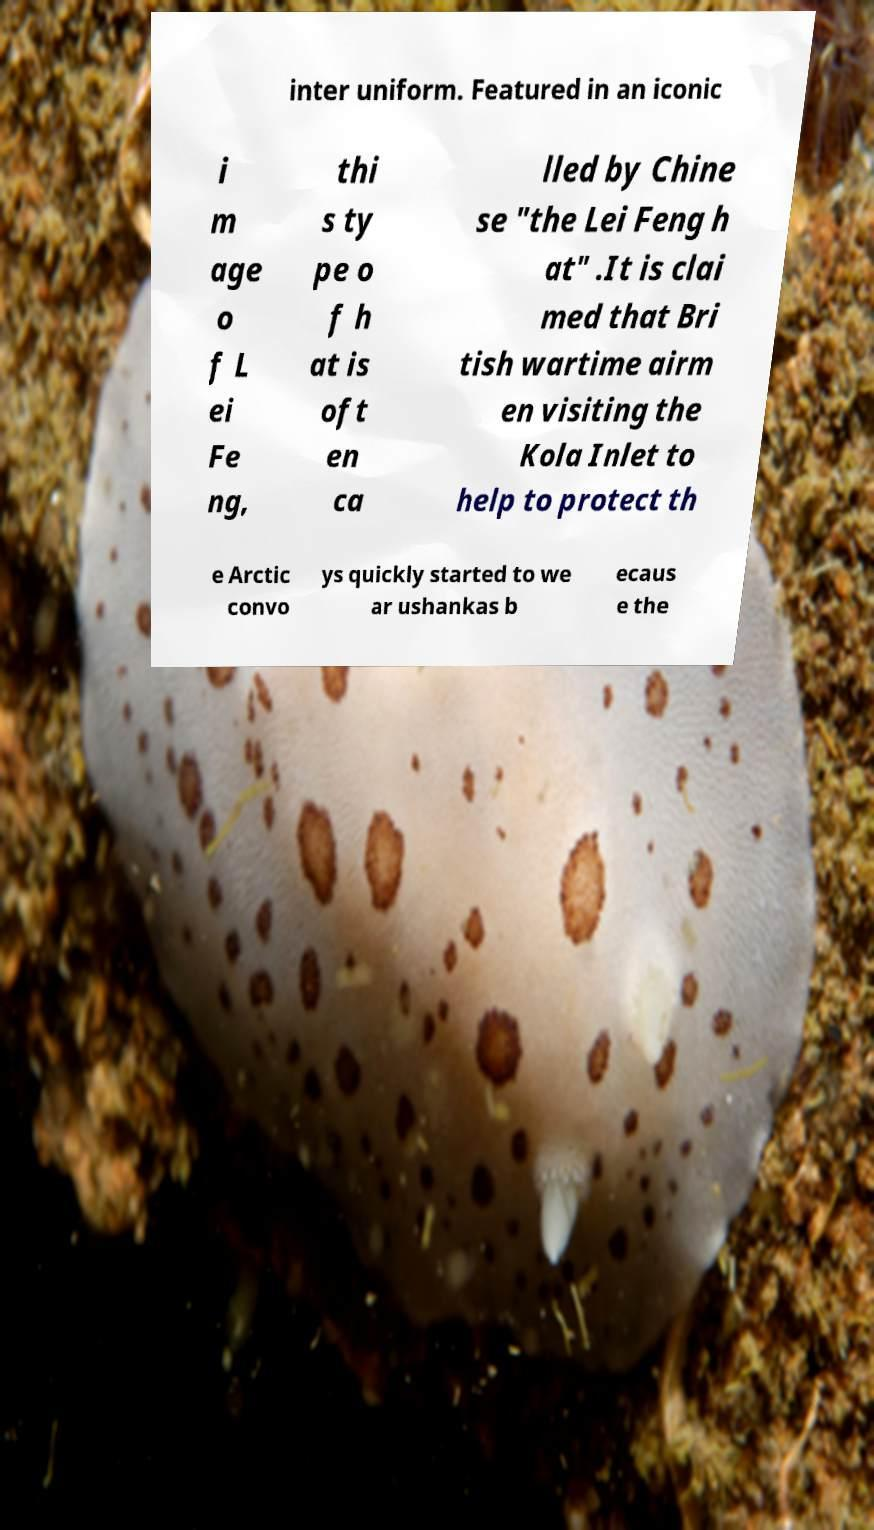Can you read and provide the text displayed in the image?This photo seems to have some interesting text. Can you extract and type it out for me? inter uniform. Featured in an iconic i m age o f L ei Fe ng, thi s ty pe o f h at is oft en ca lled by Chine se "the Lei Feng h at" .It is clai med that Bri tish wartime airm en visiting the Kola Inlet to help to protect th e Arctic convo ys quickly started to we ar ushankas b ecaus e the 